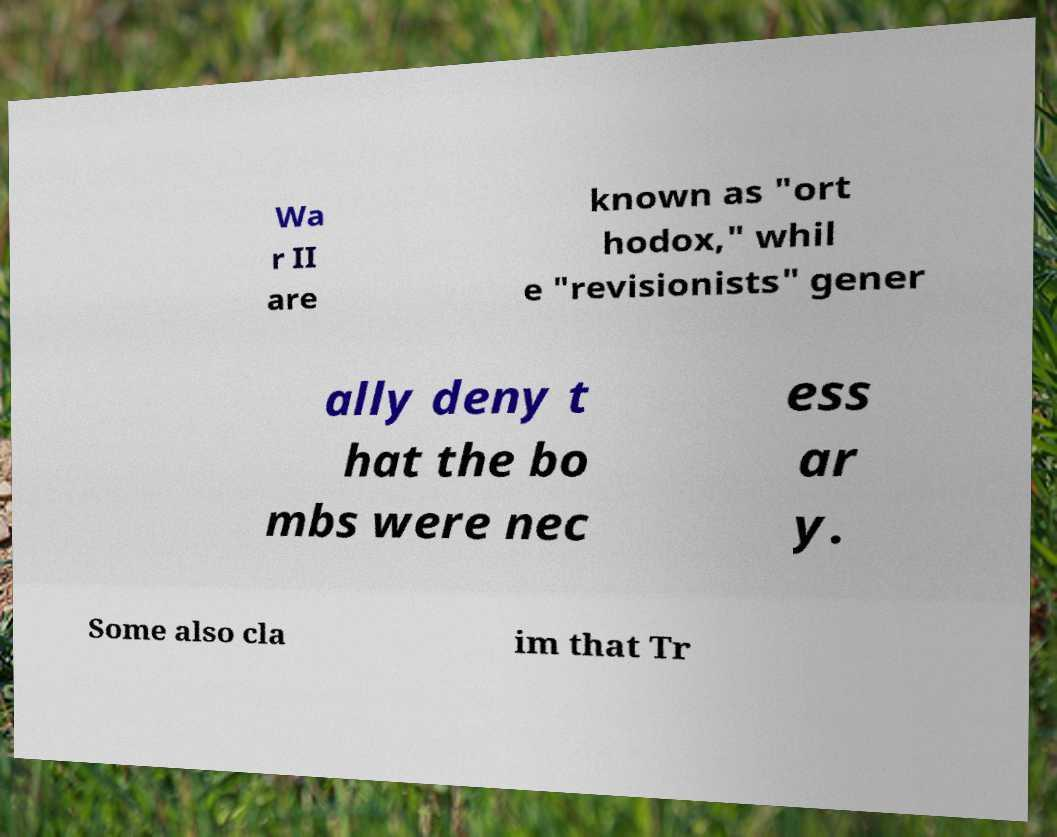Please read and relay the text visible in this image. What does it say? Wa r II are known as "ort hodox," whil e "revisionists" gener ally deny t hat the bo mbs were nec ess ar y. Some also cla im that Tr 